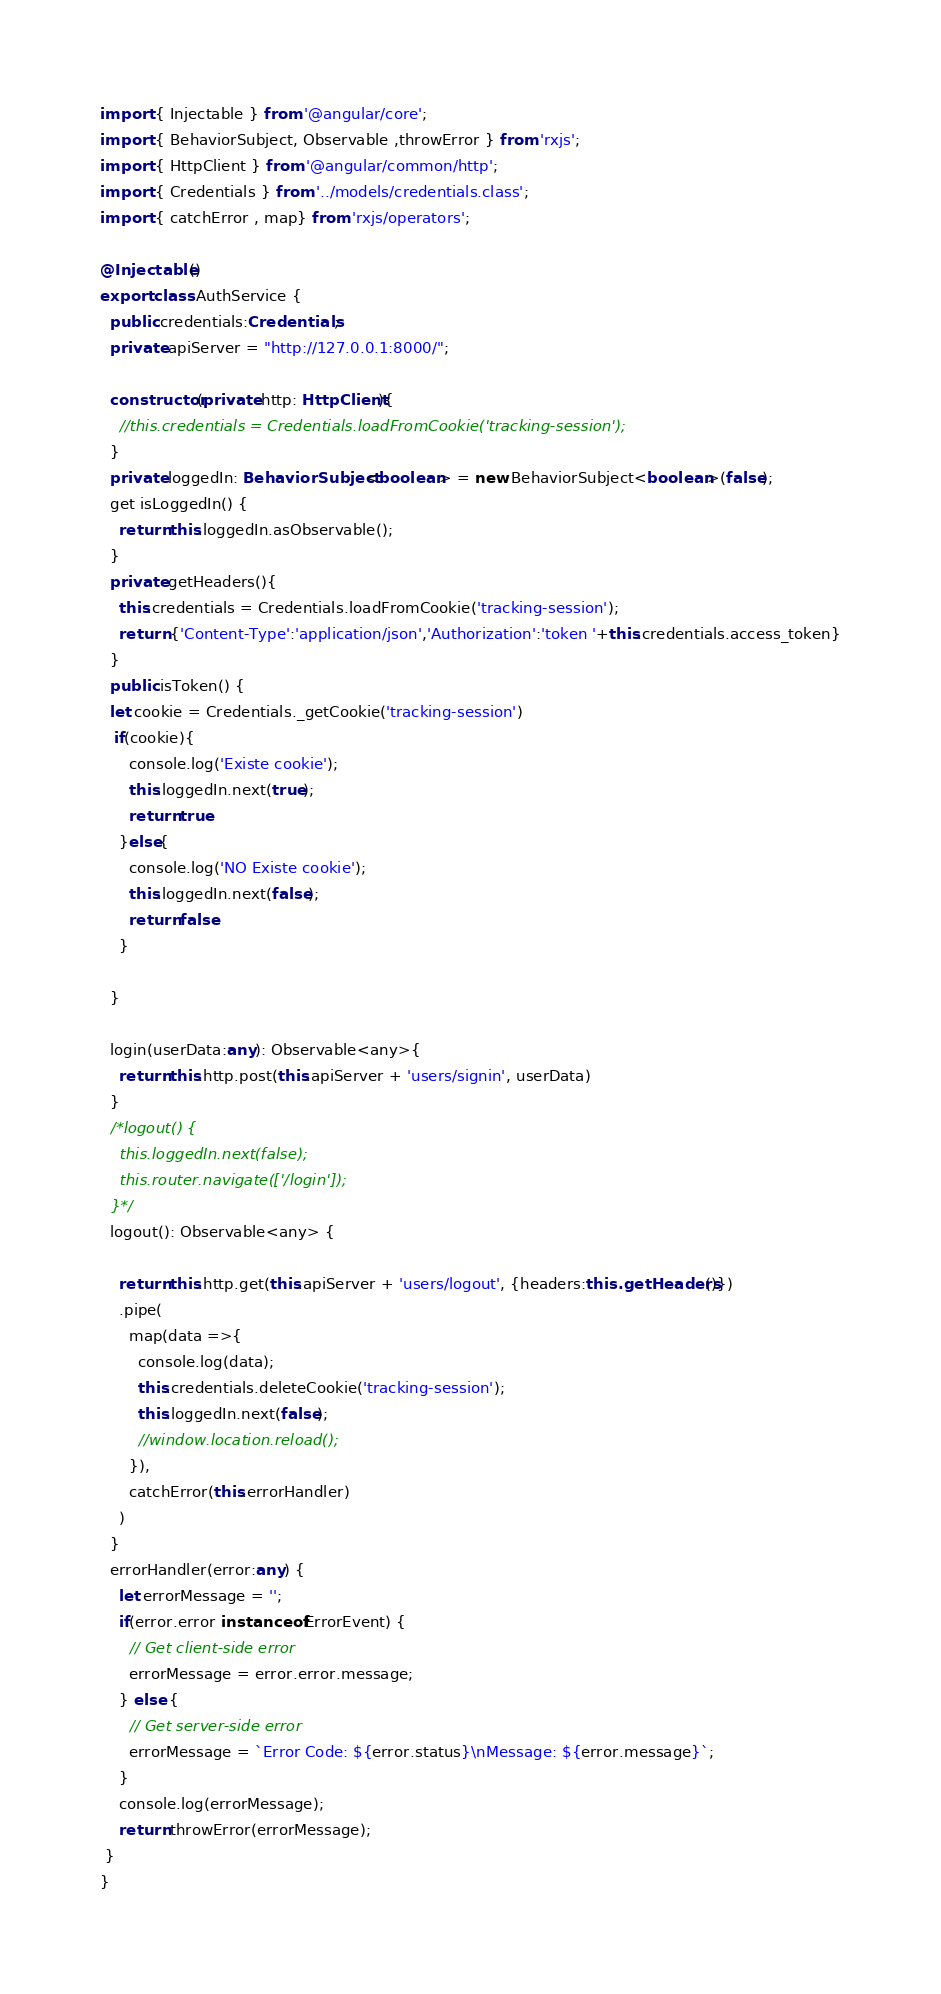<code> <loc_0><loc_0><loc_500><loc_500><_TypeScript_>import { Injectable } from '@angular/core';
import { BehaviorSubject, Observable ,throwError } from 'rxjs';
import { HttpClient } from '@angular/common/http';
import { Credentials } from '../models/credentials.class';
import { catchError , map} from 'rxjs/operators';

@Injectable()
export class AuthService {
  public credentials:Credentials;
  private apiServer = "http://127.0.0.1:8000/";

  constructor(private http: HttpClient){
    //this.credentials = Credentials.loadFromCookie('tracking-session');
  }
  private loggedIn: BehaviorSubject<boolean> = new BehaviorSubject<boolean>(false);
  get isLoggedIn() {
    return this.loggedIn.asObservable();
  }
  private getHeaders(){
    this.credentials = Credentials.loadFromCookie('tracking-session');
    return {'Content-Type':'application/json','Authorization':'token '+this.credentials.access_token}
  }
  public isToken() {
  let cookie = Credentials._getCookie('tracking-session')
   if(cookie){
      console.log('Existe cookie');
      this.loggedIn.next(true);
      return true
    }else{
      console.log('NO Existe cookie');
      this.loggedIn.next(false);
      return false
    }
  
  }

  login(userData:any): Observable<any>{
    return this.http.post(this.apiServer + 'users/signin', userData)
  }
  /*logout() {
    this.loggedIn.next(false);
    this.router.navigate(['/login']);
  }*/
  logout(): Observable<any> {
    
    return this.http.get(this.apiServer + 'users/logout', {headers:this.getHeaders()})
    .pipe(
      map(data =>{
        console.log(data);
        this.credentials.deleteCookie('tracking-session');
        this.loggedIn.next(false);
        //window.location.reload();
      }),
      catchError(this.errorHandler)
    )
  }  
  errorHandler(error:any) {
    let errorMessage = '';
    if(error.error instanceof ErrorEvent) {
      // Get client-side error
      errorMessage = error.error.message;
    } else {
      // Get server-side error
      errorMessage = `Error Code: ${error.status}\nMessage: ${error.message}`;
    }
    console.log(errorMessage);
    return throwError(errorMessage);
 }
}</code> 